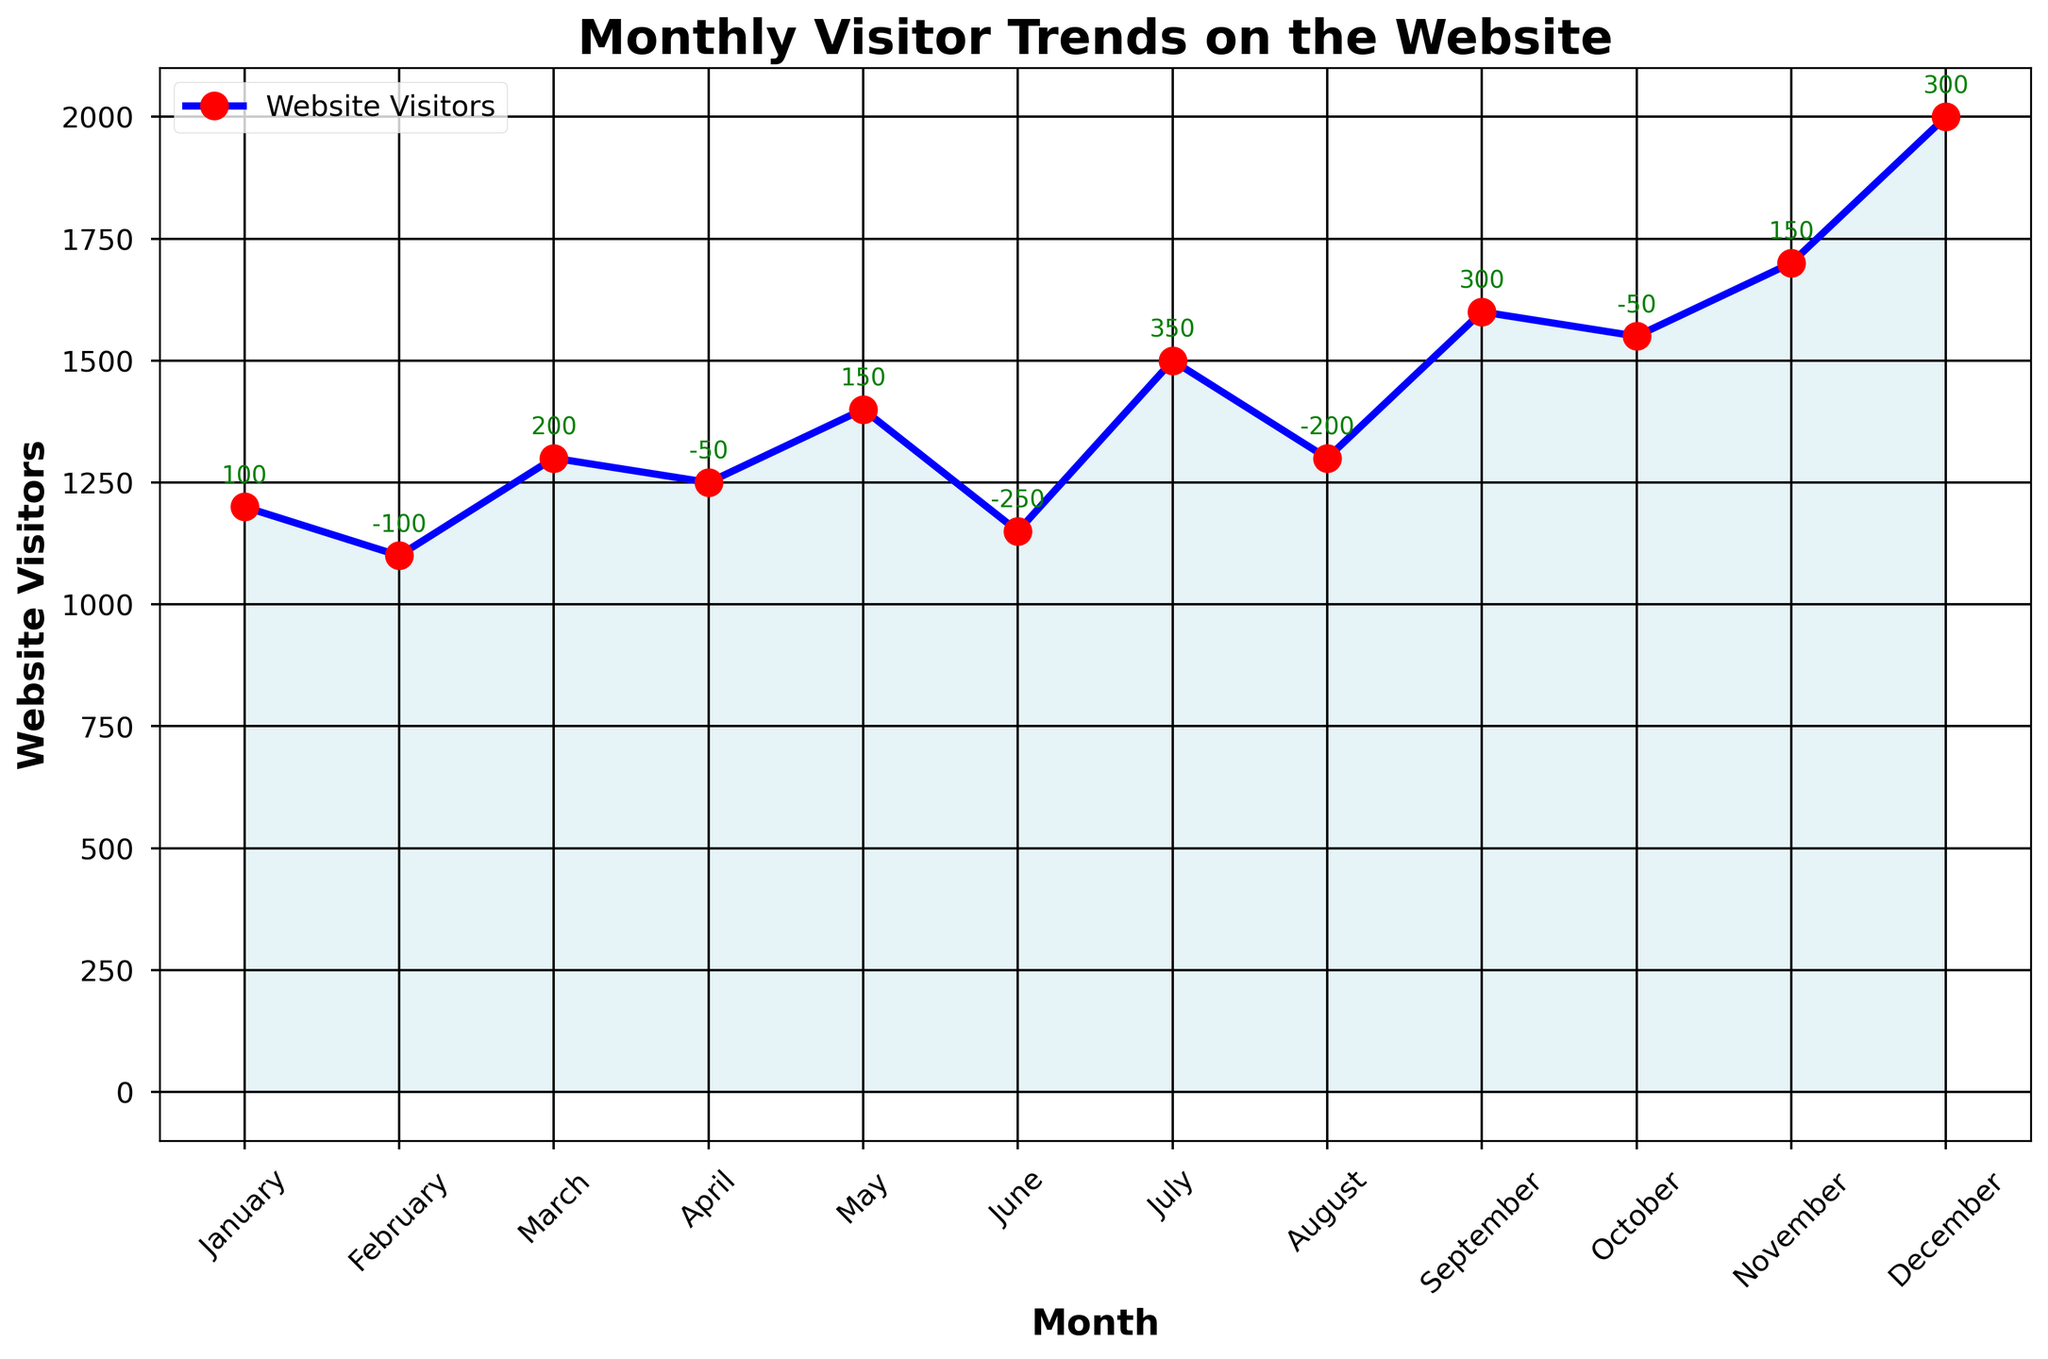What's the highest number of website visitors in a single month? By examining the chart, we see that December has the highest number of website visitors with a peak reaching up to 2,000.
Answer: 2,000 Which month had the largest increase in visitors compared to the previous month? To find this, we need to compare the change in visitors for each month. July had the largest increase with a change of +350 visitors.
Answer: July How many months had a decrease in website visitors compared to the previous month? By counting the negative values in the 'Change_in_Visitors' annotations on the chart, we find that February, April, June, August, and October had decreases. Thus, 5 months had a decrease.
Answer: 5 What's the average number of website visitors over the year? To find the average, sum the monthly visitors and divide by 12. The sum is 17,000 (1200+1100+1300+1250+1400+1150+1500+1300+1600+1550+1700+2000). The average is 17,000 / 12 = 1,417.
Answer: 1,417 Compare the number of visitors in March and September. Which month had more visitors and by how much? March had 1,300 visitors and September had 1,600 visitors. Thus, September had 1,600 - 1,300 = 300 more visitors than March.
Answer: September by 300 What was the total increase in visitors for the entire year? Sum all the positive changes in visitors. The positive changes are 100, 200, 150, 350, 300, and 150. The total increase is 100 + 200 + 150 + 350 + 300 + 150 = 1,250.
Answer: 1,250 Which month experienced the largest drop in the number of visitors? June saw the largest drop with a decrease of -250 visitors.
Answer: June By how much did the number of visitors change from January to December? January had 1,200 visitors and December had 2,000 visitors. The change is 2,000 - 1,200 = 800.
Answer: 800 What is the trend of website visitors during the second half of the year (July to December)? Observing the chart from July (1,500) to December (2,000), the visitor count first decreases in August, then steadily increases each month through December, showing an overall rising trend.
Answer: Increasing What's the lowest number of visitors in a single month? Examine the chart to find the month with the lowest point. February has the lowest number of website visitors with 1,100.
Answer: 1,100 